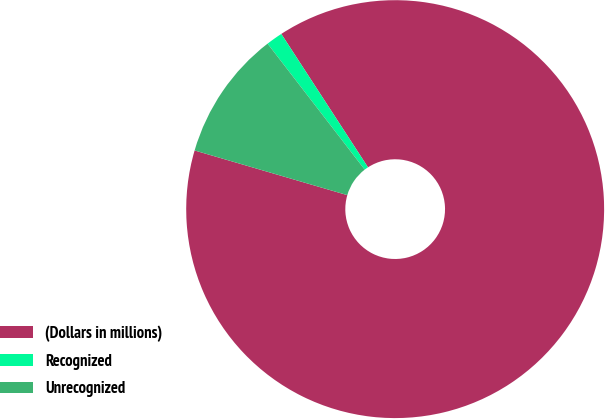<chart> <loc_0><loc_0><loc_500><loc_500><pie_chart><fcel>(Dollars in millions)<fcel>Recognized<fcel>Unrecognized<nl><fcel>88.71%<fcel>1.28%<fcel>10.02%<nl></chart> 